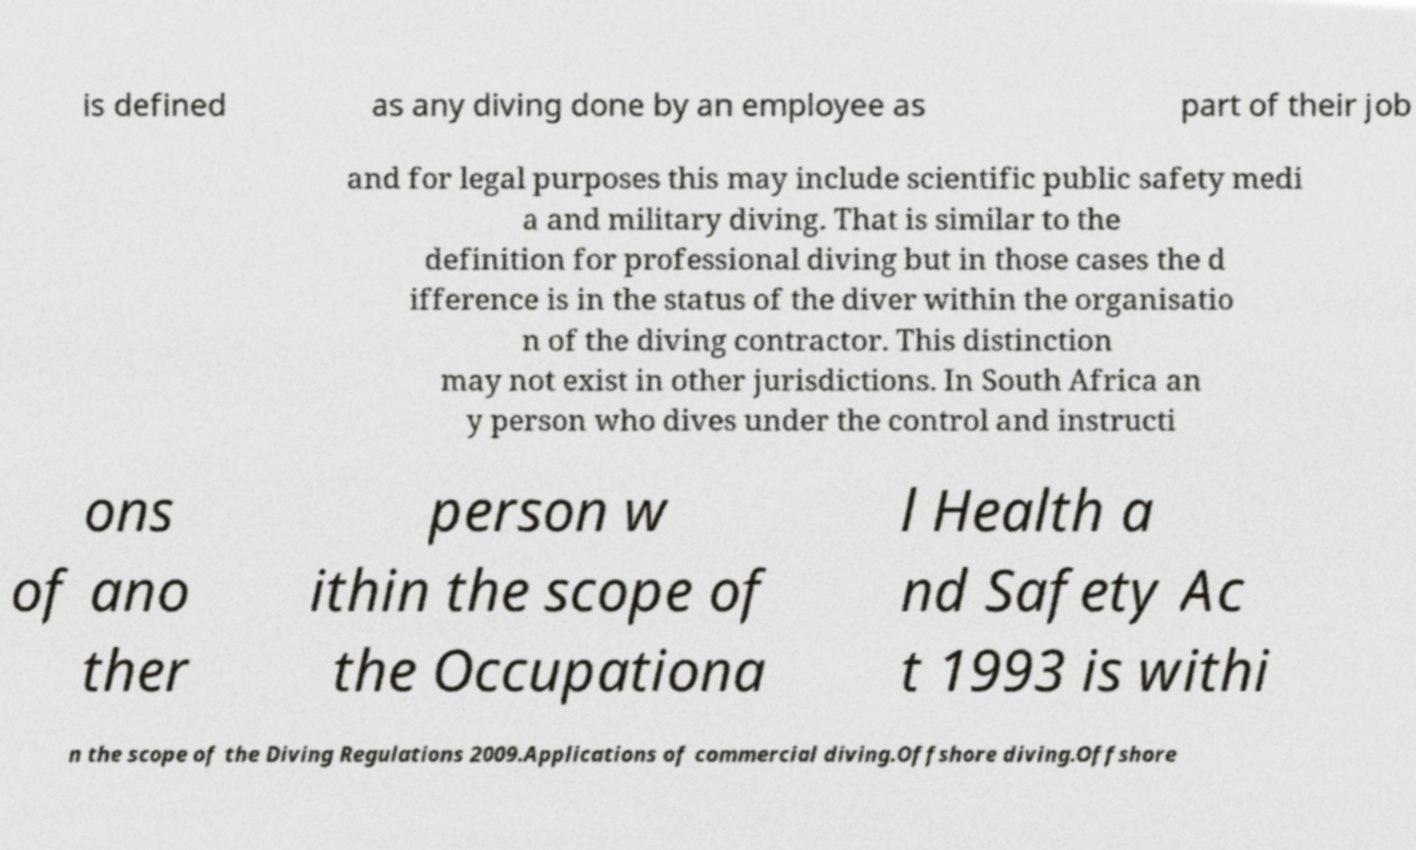Please identify and transcribe the text found in this image. is defined as any diving done by an employee as part of their job and for legal purposes this may include scientific public safety medi a and military diving. That is similar to the definition for professional diving but in those cases the d ifference is in the status of the diver within the organisatio n of the diving contractor. This distinction may not exist in other jurisdictions. In South Africa an y person who dives under the control and instructi ons of ano ther person w ithin the scope of the Occupationa l Health a nd Safety Ac t 1993 is withi n the scope of the Diving Regulations 2009.Applications of commercial diving.Offshore diving.Offshore 